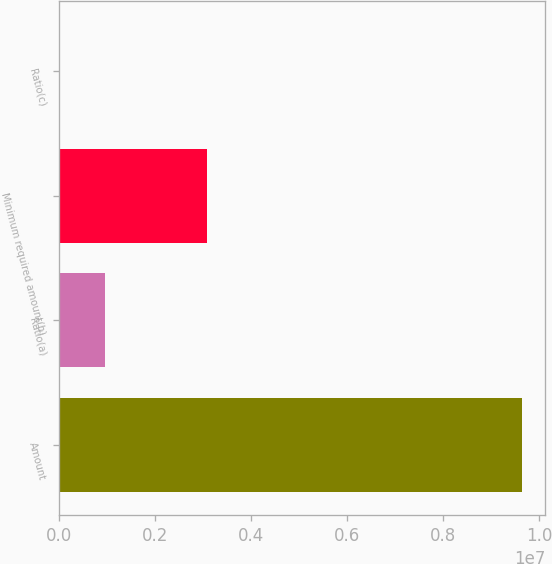Convert chart to OTSL. <chart><loc_0><loc_0><loc_500><loc_500><bar_chart><fcel>Amount<fcel>Ratio(a)<fcel>Minimum required amount(b)<fcel>Ratio(c)<nl><fcel>9.64476e+06<fcel>964486<fcel>3.09387e+06<fcel>10.17<nl></chart> 